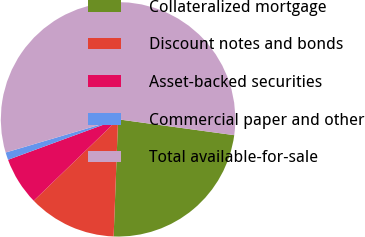<chart> <loc_0><loc_0><loc_500><loc_500><pie_chart><fcel>Collateralized mortgage<fcel>Discount notes and bonds<fcel>Asset-backed securities<fcel>Commercial paper and other<fcel>Total available-for-sale<nl><fcel>23.45%<fcel>12.18%<fcel>6.61%<fcel>1.04%<fcel>56.74%<nl></chart> 